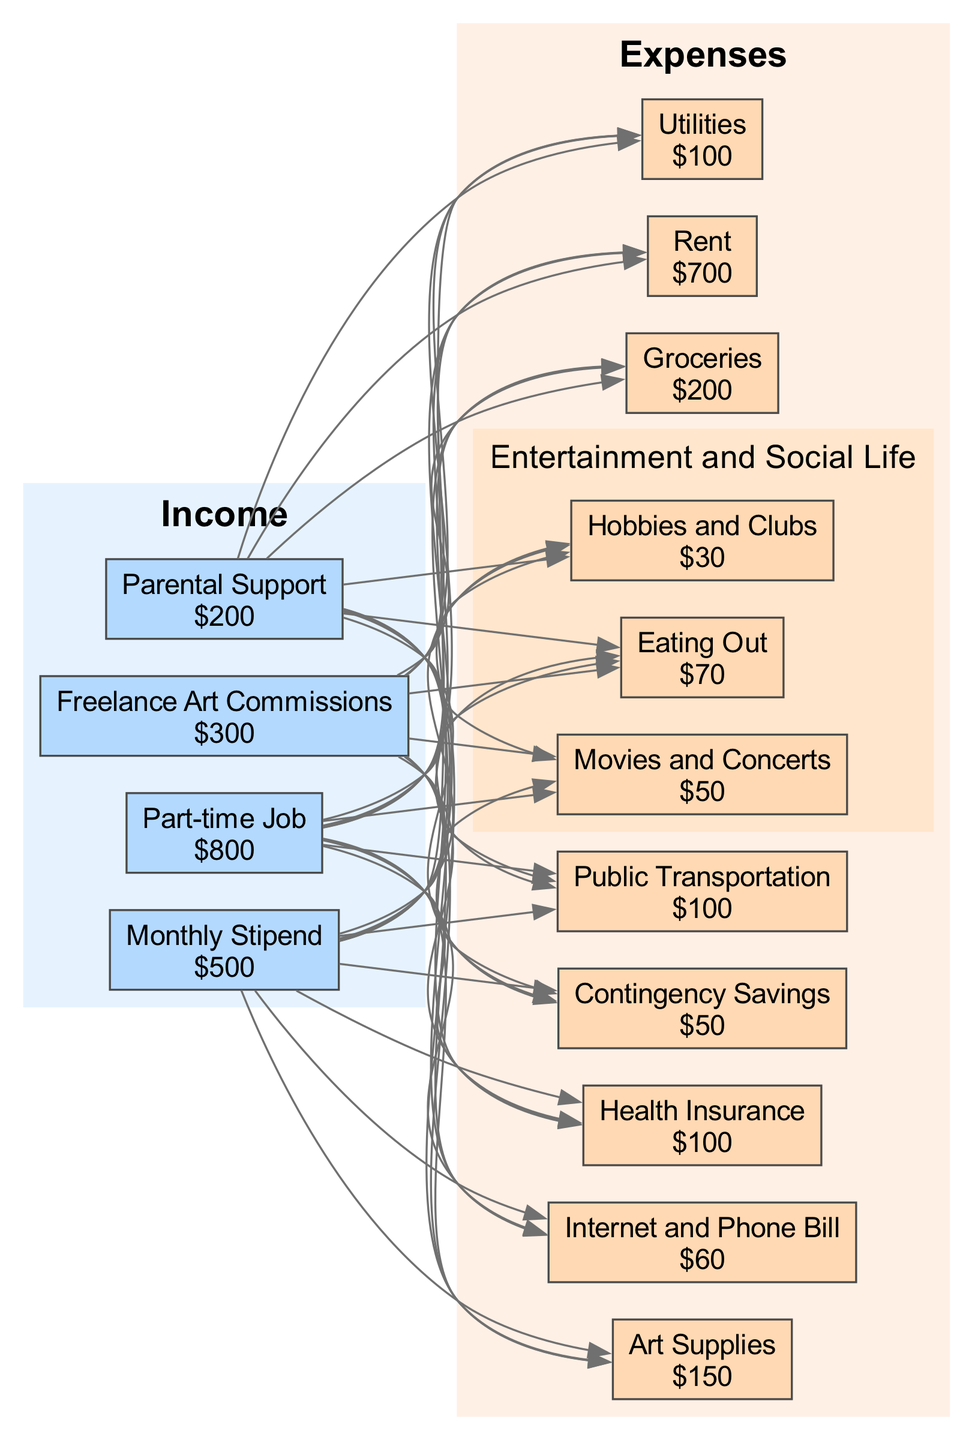What is the total monthly income? To find the total monthly income, we add all the income sources: Monthly Stipend ($500) + Part-time Job ($800) + Freelance Art Commissions ($300) + Parental Support ($200) = $1800.
Answer: $1800 What is the amount allocated for rent? The rent amount is listed directly in the expenses section as $700.
Answer: $700 How many main expense categories are there? The main expense categories are Rent, Utilities, Groceries, Public Transportation, Art Supplies, Internet and Phone Bill, Health Insurance, Entertainment and Social Life, and Contingency Savings. Counting these gives us 9 main categories.
Answer: 9 What is the expense for groceries compared to utilities? The expense for groceries is $200, which is double the expense for utilities, which is $100. This comparison shows the relation of these two values directly in the expenses section.
Answer: Groceries are double Utilities Which expense has the highest amount? The expense with the highest amount among all the listed categories is Rent, which is $700.
Answer: Rent What is the total amount spent on entertainment and social life? The total amount spent on Entertainment and Social Life can be found by adding the sub-expenses: Movies and Concerts ($50), Eating Out ($70), and Hobbies and Clubs ($30). Thus, $50 + $70 + $30 = $150.
Answer: $150 Which income source has the least value? The income source with the least value is Parental Support, which amounts to $200.
Answer: $200 What is the total amount of contingency savings? The amount for Contingency Savings is specifically listed as $50 in the expenses section.
Answer: $50 What percentage of total income goes to art supplies? To find the percentage of income allocated to Art Supplies, we divide the expense for Art Supplies ($150) by the total income ($1800) and multiply by 100. (150/1800) * 100 = 8.33%.
Answer: Approximately 8.33% 